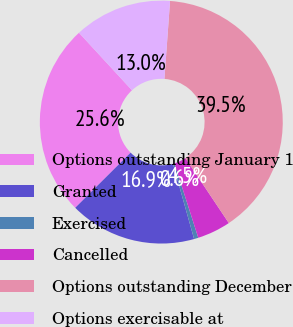Convert chart to OTSL. <chart><loc_0><loc_0><loc_500><loc_500><pie_chart><fcel>Options outstanding January 1<fcel>Granted<fcel>Exercised<fcel>Cancelled<fcel>Options outstanding December<fcel>Options exercisable at<nl><fcel>25.61%<fcel>16.89%<fcel>0.57%<fcel>4.46%<fcel>39.47%<fcel>13.0%<nl></chart> 